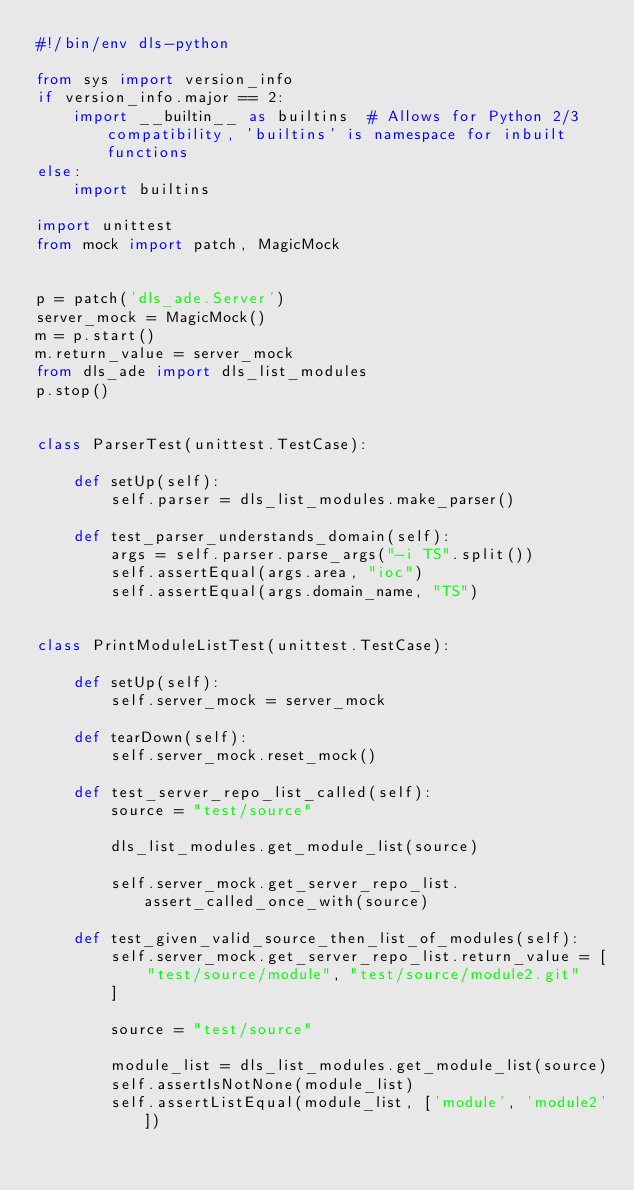<code> <loc_0><loc_0><loc_500><loc_500><_Python_>#!/bin/env dls-python

from sys import version_info
if version_info.major == 2:
    import __builtin__ as builtins  # Allows for Python 2/3 compatibility, 'builtins' is namespace for inbuilt functions
else:
    import builtins

import unittest
from mock import patch, MagicMock


p = patch('dls_ade.Server')
server_mock = MagicMock()
m = p.start()
m.return_value = server_mock
from dls_ade import dls_list_modules
p.stop()


class ParserTest(unittest.TestCase):

    def setUp(self):
        self.parser = dls_list_modules.make_parser()

    def test_parser_understands_domain(self):
        args = self.parser.parse_args("-i TS".split())
        self.assertEqual(args.area, "ioc")
        self.assertEqual(args.domain_name, "TS")


class PrintModuleListTest(unittest.TestCase):

    def setUp(self):
        self.server_mock = server_mock

    def tearDown(self):
        self.server_mock.reset_mock()

    def test_server_repo_list_called(self):
        source = "test/source"

        dls_list_modules.get_module_list(source)

        self.server_mock.get_server_repo_list.assert_called_once_with(source)

    def test_given_valid_source_then_list_of_modules(self):
        self.server_mock.get_server_repo_list.return_value = [
            "test/source/module", "test/source/module2.git"
        ]

        source = "test/source"

        module_list = dls_list_modules.get_module_list(source)
        self.assertIsNotNone(module_list)
        self.assertListEqual(module_list, ['module', 'module2'])
</code> 